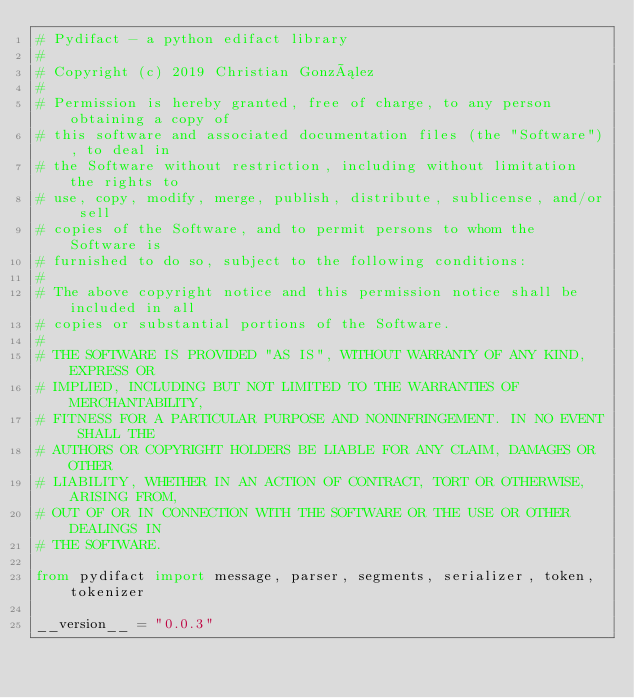<code> <loc_0><loc_0><loc_500><loc_500><_Python_># Pydifact - a python edifact library
#
# Copyright (c) 2019 Christian González
#
# Permission is hereby granted, free of charge, to any person obtaining a copy of
# this software and associated documentation files (the "Software"), to deal in
# the Software without restriction, including without limitation the rights to
# use, copy, modify, merge, publish, distribute, sublicense, and/or sell
# copies of the Software, and to permit persons to whom the Software is
# furnished to do so, subject to the following conditions:
#
# The above copyright notice and this permission notice shall be included in all
# copies or substantial portions of the Software.
#
# THE SOFTWARE IS PROVIDED "AS IS", WITHOUT WARRANTY OF ANY KIND, EXPRESS OR
# IMPLIED, INCLUDING BUT NOT LIMITED TO THE WARRANTIES OF MERCHANTABILITY,
# FITNESS FOR A PARTICULAR PURPOSE AND NONINFRINGEMENT. IN NO EVENT SHALL THE
# AUTHORS OR COPYRIGHT HOLDERS BE LIABLE FOR ANY CLAIM, DAMAGES OR OTHER
# LIABILITY, WHETHER IN AN ACTION OF CONTRACT, TORT OR OTHERWISE, ARISING FROM,
# OUT OF OR IN CONNECTION WITH THE SOFTWARE OR THE USE OR OTHER DEALINGS IN
# THE SOFTWARE.

from pydifact import message, parser, segments, serializer, token, tokenizer

__version__ = "0.0.3"
</code> 